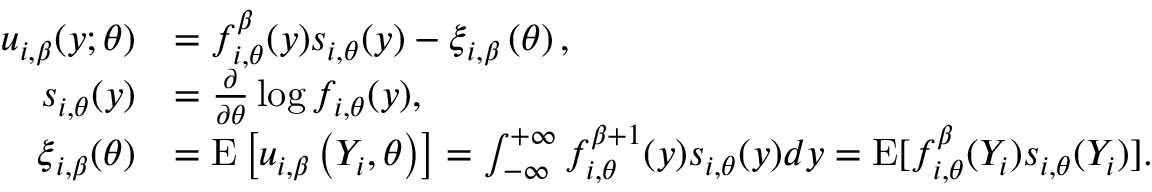Convert formula to latex. <formula><loc_0><loc_0><loc_500><loc_500>\begin{array} { r l } { u _ { i , \beta } ( y ; \theta ) } & { = f _ { i , \theta } ^ { \beta } ( y ) s _ { i , \theta } ( y ) - \xi _ { i , \beta } \left ( \theta \right ) , } \\ { s _ { i , \theta } ( y ) } & { = \frac { \partial } { \partial \theta } \log f _ { i , \theta } ( y ) , } \\ { \xi _ { i , \beta } ( \theta ) } & { = E \left [ u _ { i , \beta } \left ( Y _ { i } , \theta \right ) \right ] = \int _ { \mathcal { - \infty } } ^ { + \infty } f _ { i , \theta } ^ { \beta + 1 } ( y ) s _ { i , \theta } ( y ) d y = E [ f _ { i , \theta } ^ { \beta } ( Y _ { i } ) s _ { i , \theta } ( Y _ { i } ) ] . } \end{array}</formula> 